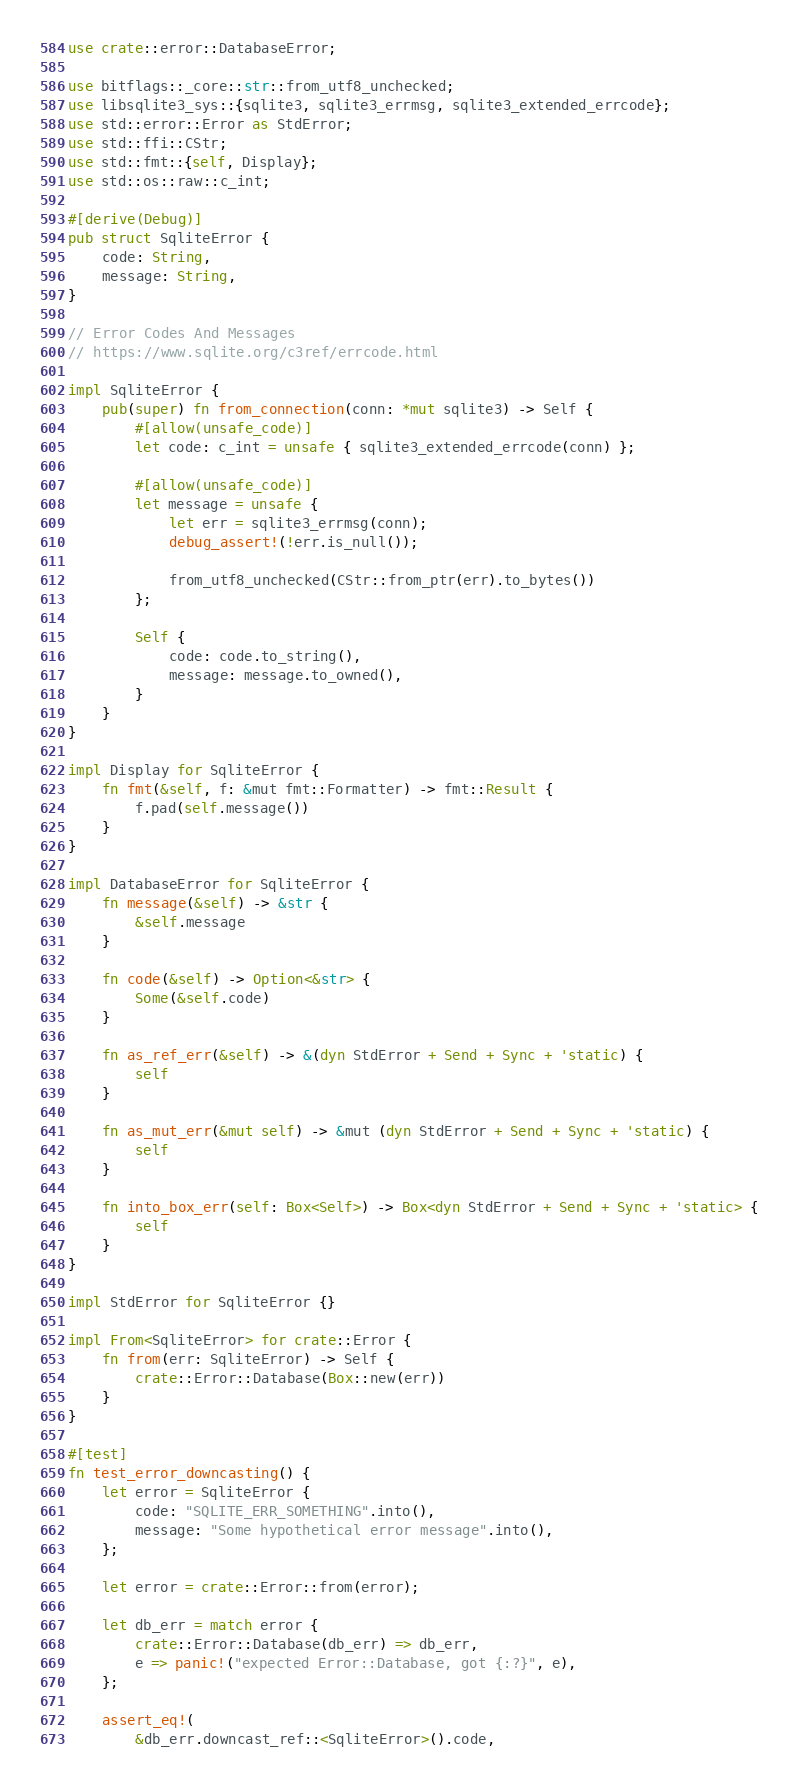<code> <loc_0><loc_0><loc_500><loc_500><_Rust_>use crate::error::DatabaseError;

use bitflags::_core::str::from_utf8_unchecked;
use libsqlite3_sys::{sqlite3, sqlite3_errmsg, sqlite3_extended_errcode};
use std::error::Error as StdError;
use std::ffi::CStr;
use std::fmt::{self, Display};
use std::os::raw::c_int;

#[derive(Debug)]
pub struct SqliteError {
    code: String,
    message: String,
}

// Error Codes And Messages
// https://www.sqlite.org/c3ref/errcode.html

impl SqliteError {
    pub(super) fn from_connection(conn: *mut sqlite3) -> Self {
        #[allow(unsafe_code)]
        let code: c_int = unsafe { sqlite3_extended_errcode(conn) };

        #[allow(unsafe_code)]
        let message = unsafe {
            let err = sqlite3_errmsg(conn);
            debug_assert!(!err.is_null());

            from_utf8_unchecked(CStr::from_ptr(err).to_bytes())
        };

        Self {
            code: code.to_string(),
            message: message.to_owned(),
        }
    }
}

impl Display for SqliteError {
    fn fmt(&self, f: &mut fmt::Formatter) -> fmt::Result {
        f.pad(self.message())
    }
}

impl DatabaseError for SqliteError {
    fn message(&self) -> &str {
        &self.message
    }

    fn code(&self) -> Option<&str> {
        Some(&self.code)
    }

    fn as_ref_err(&self) -> &(dyn StdError + Send + Sync + 'static) {
        self
    }

    fn as_mut_err(&mut self) -> &mut (dyn StdError + Send + Sync + 'static) {
        self
    }

    fn into_box_err(self: Box<Self>) -> Box<dyn StdError + Send + Sync + 'static> {
        self
    }
}

impl StdError for SqliteError {}

impl From<SqliteError> for crate::Error {
    fn from(err: SqliteError) -> Self {
        crate::Error::Database(Box::new(err))
    }
}

#[test]
fn test_error_downcasting() {
    let error = SqliteError {
        code: "SQLITE_ERR_SOMETHING".into(),
        message: "Some hypothetical error message".into(),
    };

    let error = crate::Error::from(error);

    let db_err = match error {
        crate::Error::Database(db_err) => db_err,
        e => panic!("expected Error::Database, got {:?}", e),
    };

    assert_eq!(
        &db_err.downcast_ref::<SqliteError>().code,</code> 